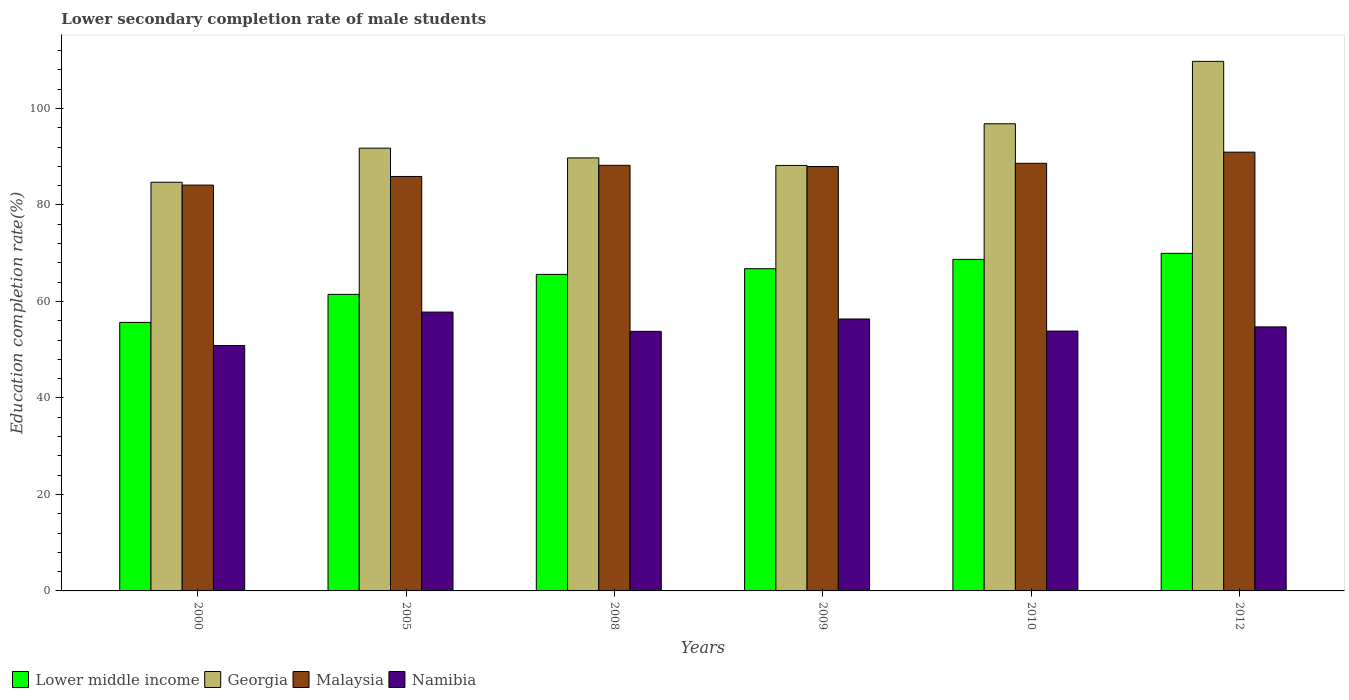How many different coloured bars are there?
Your response must be concise. 4. How many groups of bars are there?
Provide a short and direct response. 6. Are the number of bars per tick equal to the number of legend labels?
Your response must be concise. Yes. What is the lower secondary completion rate of male students in Namibia in 2005?
Keep it short and to the point. 57.8. Across all years, what is the maximum lower secondary completion rate of male students in Georgia?
Provide a succinct answer. 109.76. Across all years, what is the minimum lower secondary completion rate of male students in Namibia?
Keep it short and to the point. 50.86. In which year was the lower secondary completion rate of male students in Georgia maximum?
Provide a short and direct response. 2012. In which year was the lower secondary completion rate of male students in Malaysia minimum?
Ensure brevity in your answer.  2000. What is the total lower secondary completion rate of male students in Georgia in the graph?
Make the answer very short. 560.99. What is the difference between the lower secondary completion rate of male students in Lower middle income in 2008 and that in 2012?
Make the answer very short. -4.36. What is the difference between the lower secondary completion rate of male students in Georgia in 2005 and the lower secondary completion rate of male students in Namibia in 2012?
Keep it short and to the point. 37.04. What is the average lower secondary completion rate of male students in Georgia per year?
Your response must be concise. 93.5. In the year 2005, what is the difference between the lower secondary completion rate of male students in Georgia and lower secondary completion rate of male students in Namibia?
Your answer should be compact. 33.97. What is the ratio of the lower secondary completion rate of male students in Lower middle income in 2010 to that in 2012?
Offer a very short reply. 0.98. Is the lower secondary completion rate of male students in Namibia in 2008 less than that in 2009?
Your response must be concise. Yes. Is the difference between the lower secondary completion rate of male students in Georgia in 2009 and 2012 greater than the difference between the lower secondary completion rate of male students in Namibia in 2009 and 2012?
Give a very brief answer. No. What is the difference between the highest and the second highest lower secondary completion rate of male students in Malaysia?
Your answer should be compact. 2.31. What is the difference between the highest and the lowest lower secondary completion rate of male students in Lower middle income?
Provide a succinct answer. 14.31. Is the sum of the lower secondary completion rate of male students in Lower middle income in 2009 and 2010 greater than the maximum lower secondary completion rate of male students in Georgia across all years?
Your response must be concise. Yes. What does the 2nd bar from the left in 2010 represents?
Provide a short and direct response. Georgia. What does the 3rd bar from the right in 2000 represents?
Offer a terse response. Georgia. Is it the case that in every year, the sum of the lower secondary completion rate of male students in Malaysia and lower secondary completion rate of male students in Namibia is greater than the lower secondary completion rate of male students in Lower middle income?
Make the answer very short. Yes. How many bars are there?
Offer a terse response. 24. Does the graph contain any zero values?
Provide a succinct answer. No. Where does the legend appear in the graph?
Offer a terse response. Bottom left. How many legend labels are there?
Your answer should be compact. 4. What is the title of the graph?
Offer a terse response. Lower secondary completion rate of male students. What is the label or title of the X-axis?
Give a very brief answer. Years. What is the label or title of the Y-axis?
Offer a terse response. Education completion rate(%). What is the Education completion rate(%) of Lower middle income in 2000?
Offer a terse response. 55.66. What is the Education completion rate(%) of Georgia in 2000?
Make the answer very short. 84.7. What is the Education completion rate(%) in Malaysia in 2000?
Your answer should be very brief. 84.11. What is the Education completion rate(%) in Namibia in 2000?
Give a very brief answer. 50.86. What is the Education completion rate(%) of Lower middle income in 2005?
Provide a succinct answer. 61.47. What is the Education completion rate(%) of Georgia in 2005?
Keep it short and to the point. 91.77. What is the Education completion rate(%) in Malaysia in 2005?
Your answer should be very brief. 85.9. What is the Education completion rate(%) in Namibia in 2005?
Give a very brief answer. 57.8. What is the Education completion rate(%) of Lower middle income in 2008?
Keep it short and to the point. 65.6. What is the Education completion rate(%) of Georgia in 2008?
Offer a terse response. 89.75. What is the Education completion rate(%) of Malaysia in 2008?
Your answer should be compact. 88.21. What is the Education completion rate(%) of Namibia in 2008?
Make the answer very short. 53.8. What is the Education completion rate(%) of Lower middle income in 2009?
Make the answer very short. 66.78. What is the Education completion rate(%) in Georgia in 2009?
Offer a very short reply. 88.19. What is the Education completion rate(%) in Malaysia in 2009?
Keep it short and to the point. 87.96. What is the Education completion rate(%) in Namibia in 2009?
Your answer should be very brief. 56.36. What is the Education completion rate(%) of Lower middle income in 2010?
Make the answer very short. 68.71. What is the Education completion rate(%) of Georgia in 2010?
Give a very brief answer. 96.83. What is the Education completion rate(%) of Malaysia in 2010?
Offer a very short reply. 88.63. What is the Education completion rate(%) in Namibia in 2010?
Provide a short and direct response. 53.86. What is the Education completion rate(%) in Lower middle income in 2012?
Keep it short and to the point. 69.97. What is the Education completion rate(%) in Georgia in 2012?
Your answer should be compact. 109.76. What is the Education completion rate(%) of Malaysia in 2012?
Give a very brief answer. 90.94. What is the Education completion rate(%) of Namibia in 2012?
Make the answer very short. 54.73. Across all years, what is the maximum Education completion rate(%) in Lower middle income?
Your response must be concise. 69.97. Across all years, what is the maximum Education completion rate(%) in Georgia?
Your answer should be very brief. 109.76. Across all years, what is the maximum Education completion rate(%) in Malaysia?
Provide a succinct answer. 90.94. Across all years, what is the maximum Education completion rate(%) of Namibia?
Ensure brevity in your answer.  57.8. Across all years, what is the minimum Education completion rate(%) of Lower middle income?
Give a very brief answer. 55.66. Across all years, what is the minimum Education completion rate(%) in Georgia?
Give a very brief answer. 84.7. Across all years, what is the minimum Education completion rate(%) of Malaysia?
Offer a very short reply. 84.11. Across all years, what is the minimum Education completion rate(%) of Namibia?
Your answer should be very brief. 50.86. What is the total Education completion rate(%) of Lower middle income in the graph?
Your answer should be compact. 388.19. What is the total Education completion rate(%) in Georgia in the graph?
Ensure brevity in your answer.  560.99. What is the total Education completion rate(%) of Malaysia in the graph?
Make the answer very short. 525.76. What is the total Education completion rate(%) in Namibia in the graph?
Provide a succinct answer. 327.4. What is the difference between the Education completion rate(%) of Lower middle income in 2000 and that in 2005?
Keep it short and to the point. -5.81. What is the difference between the Education completion rate(%) of Georgia in 2000 and that in 2005?
Your answer should be compact. -7.07. What is the difference between the Education completion rate(%) of Malaysia in 2000 and that in 2005?
Offer a very short reply. -1.79. What is the difference between the Education completion rate(%) in Namibia in 2000 and that in 2005?
Make the answer very short. -6.94. What is the difference between the Education completion rate(%) in Lower middle income in 2000 and that in 2008?
Keep it short and to the point. -9.95. What is the difference between the Education completion rate(%) of Georgia in 2000 and that in 2008?
Your answer should be compact. -5.05. What is the difference between the Education completion rate(%) of Malaysia in 2000 and that in 2008?
Your answer should be very brief. -4.1. What is the difference between the Education completion rate(%) in Namibia in 2000 and that in 2008?
Keep it short and to the point. -2.94. What is the difference between the Education completion rate(%) in Lower middle income in 2000 and that in 2009?
Give a very brief answer. -11.13. What is the difference between the Education completion rate(%) in Georgia in 2000 and that in 2009?
Your response must be concise. -3.48. What is the difference between the Education completion rate(%) of Malaysia in 2000 and that in 2009?
Make the answer very short. -3.86. What is the difference between the Education completion rate(%) in Namibia in 2000 and that in 2009?
Offer a very short reply. -5.5. What is the difference between the Education completion rate(%) of Lower middle income in 2000 and that in 2010?
Your answer should be very brief. -13.06. What is the difference between the Education completion rate(%) in Georgia in 2000 and that in 2010?
Your answer should be compact. -12.13. What is the difference between the Education completion rate(%) of Malaysia in 2000 and that in 2010?
Keep it short and to the point. -4.52. What is the difference between the Education completion rate(%) of Namibia in 2000 and that in 2010?
Keep it short and to the point. -3. What is the difference between the Education completion rate(%) of Lower middle income in 2000 and that in 2012?
Provide a succinct answer. -14.31. What is the difference between the Education completion rate(%) of Georgia in 2000 and that in 2012?
Keep it short and to the point. -25.06. What is the difference between the Education completion rate(%) in Malaysia in 2000 and that in 2012?
Your answer should be very brief. -6.84. What is the difference between the Education completion rate(%) in Namibia in 2000 and that in 2012?
Your answer should be compact. -3.87. What is the difference between the Education completion rate(%) in Lower middle income in 2005 and that in 2008?
Ensure brevity in your answer.  -4.14. What is the difference between the Education completion rate(%) in Georgia in 2005 and that in 2008?
Your answer should be very brief. 2.02. What is the difference between the Education completion rate(%) in Malaysia in 2005 and that in 2008?
Your answer should be very brief. -2.31. What is the difference between the Education completion rate(%) of Namibia in 2005 and that in 2008?
Make the answer very short. 3.99. What is the difference between the Education completion rate(%) of Lower middle income in 2005 and that in 2009?
Your response must be concise. -5.32. What is the difference between the Education completion rate(%) in Georgia in 2005 and that in 2009?
Provide a short and direct response. 3.58. What is the difference between the Education completion rate(%) in Malaysia in 2005 and that in 2009?
Provide a succinct answer. -2.06. What is the difference between the Education completion rate(%) of Namibia in 2005 and that in 2009?
Provide a short and direct response. 1.43. What is the difference between the Education completion rate(%) in Lower middle income in 2005 and that in 2010?
Provide a succinct answer. -7.25. What is the difference between the Education completion rate(%) of Georgia in 2005 and that in 2010?
Make the answer very short. -5.06. What is the difference between the Education completion rate(%) in Malaysia in 2005 and that in 2010?
Your answer should be compact. -2.73. What is the difference between the Education completion rate(%) of Namibia in 2005 and that in 2010?
Your response must be concise. 3.94. What is the difference between the Education completion rate(%) of Lower middle income in 2005 and that in 2012?
Offer a very short reply. -8.5. What is the difference between the Education completion rate(%) of Georgia in 2005 and that in 2012?
Provide a short and direct response. -17.99. What is the difference between the Education completion rate(%) of Malaysia in 2005 and that in 2012?
Make the answer very short. -5.04. What is the difference between the Education completion rate(%) in Namibia in 2005 and that in 2012?
Offer a terse response. 3.07. What is the difference between the Education completion rate(%) of Lower middle income in 2008 and that in 2009?
Make the answer very short. -1.18. What is the difference between the Education completion rate(%) in Georgia in 2008 and that in 2009?
Keep it short and to the point. 1.56. What is the difference between the Education completion rate(%) in Malaysia in 2008 and that in 2009?
Give a very brief answer. 0.25. What is the difference between the Education completion rate(%) of Namibia in 2008 and that in 2009?
Provide a short and direct response. -2.56. What is the difference between the Education completion rate(%) in Lower middle income in 2008 and that in 2010?
Offer a very short reply. -3.11. What is the difference between the Education completion rate(%) of Georgia in 2008 and that in 2010?
Give a very brief answer. -7.08. What is the difference between the Education completion rate(%) in Malaysia in 2008 and that in 2010?
Your answer should be very brief. -0.42. What is the difference between the Education completion rate(%) of Namibia in 2008 and that in 2010?
Offer a terse response. -0.05. What is the difference between the Education completion rate(%) in Lower middle income in 2008 and that in 2012?
Your response must be concise. -4.36. What is the difference between the Education completion rate(%) of Georgia in 2008 and that in 2012?
Your answer should be compact. -20.01. What is the difference between the Education completion rate(%) in Malaysia in 2008 and that in 2012?
Offer a very short reply. -2.73. What is the difference between the Education completion rate(%) of Namibia in 2008 and that in 2012?
Make the answer very short. -0.92. What is the difference between the Education completion rate(%) in Lower middle income in 2009 and that in 2010?
Your answer should be very brief. -1.93. What is the difference between the Education completion rate(%) in Georgia in 2009 and that in 2010?
Ensure brevity in your answer.  -8.64. What is the difference between the Education completion rate(%) in Malaysia in 2009 and that in 2010?
Offer a terse response. -0.67. What is the difference between the Education completion rate(%) of Namibia in 2009 and that in 2010?
Your answer should be compact. 2.5. What is the difference between the Education completion rate(%) in Lower middle income in 2009 and that in 2012?
Offer a very short reply. -3.18. What is the difference between the Education completion rate(%) of Georgia in 2009 and that in 2012?
Ensure brevity in your answer.  -21.57. What is the difference between the Education completion rate(%) in Malaysia in 2009 and that in 2012?
Your answer should be very brief. -2.98. What is the difference between the Education completion rate(%) in Namibia in 2009 and that in 2012?
Your answer should be compact. 1.64. What is the difference between the Education completion rate(%) in Lower middle income in 2010 and that in 2012?
Offer a very short reply. -1.25. What is the difference between the Education completion rate(%) in Georgia in 2010 and that in 2012?
Your answer should be very brief. -12.93. What is the difference between the Education completion rate(%) of Malaysia in 2010 and that in 2012?
Ensure brevity in your answer.  -2.31. What is the difference between the Education completion rate(%) of Namibia in 2010 and that in 2012?
Your answer should be very brief. -0.87. What is the difference between the Education completion rate(%) in Lower middle income in 2000 and the Education completion rate(%) in Georgia in 2005?
Keep it short and to the point. -36.11. What is the difference between the Education completion rate(%) in Lower middle income in 2000 and the Education completion rate(%) in Malaysia in 2005?
Your answer should be compact. -30.25. What is the difference between the Education completion rate(%) in Lower middle income in 2000 and the Education completion rate(%) in Namibia in 2005?
Provide a succinct answer. -2.14. What is the difference between the Education completion rate(%) in Georgia in 2000 and the Education completion rate(%) in Malaysia in 2005?
Give a very brief answer. -1.2. What is the difference between the Education completion rate(%) in Georgia in 2000 and the Education completion rate(%) in Namibia in 2005?
Ensure brevity in your answer.  26.91. What is the difference between the Education completion rate(%) of Malaysia in 2000 and the Education completion rate(%) of Namibia in 2005?
Give a very brief answer. 26.31. What is the difference between the Education completion rate(%) in Lower middle income in 2000 and the Education completion rate(%) in Georgia in 2008?
Provide a short and direct response. -34.09. What is the difference between the Education completion rate(%) of Lower middle income in 2000 and the Education completion rate(%) of Malaysia in 2008?
Offer a terse response. -32.55. What is the difference between the Education completion rate(%) in Lower middle income in 2000 and the Education completion rate(%) in Namibia in 2008?
Give a very brief answer. 1.85. What is the difference between the Education completion rate(%) in Georgia in 2000 and the Education completion rate(%) in Malaysia in 2008?
Your answer should be compact. -3.51. What is the difference between the Education completion rate(%) of Georgia in 2000 and the Education completion rate(%) of Namibia in 2008?
Keep it short and to the point. 30.9. What is the difference between the Education completion rate(%) in Malaysia in 2000 and the Education completion rate(%) in Namibia in 2008?
Ensure brevity in your answer.  30.3. What is the difference between the Education completion rate(%) in Lower middle income in 2000 and the Education completion rate(%) in Georgia in 2009?
Your response must be concise. -32.53. What is the difference between the Education completion rate(%) in Lower middle income in 2000 and the Education completion rate(%) in Malaysia in 2009?
Offer a very short reply. -32.31. What is the difference between the Education completion rate(%) in Lower middle income in 2000 and the Education completion rate(%) in Namibia in 2009?
Give a very brief answer. -0.71. What is the difference between the Education completion rate(%) of Georgia in 2000 and the Education completion rate(%) of Malaysia in 2009?
Your answer should be very brief. -3.26. What is the difference between the Education completion rate(%) of Georgia in 2000 and the Education completion rate(%) of Namibia in 2009?
Provide a short and direct response. 28.34. What is the difference between the Education completion rate(%) of Malaysia in 2000 and the Education completion rate(%) of Namibia in 2009?
Make the answer very short. 27.75. What is the difference between the Education completion rate(%) of Lower middle income in 2000 and the Education completion rate(%) of Georgia in 2010?
Ensure brevity in your answer.  -41.17. What is the difference between the Education completion rate(%) in Lower middle income in 2000 and the Education completion rate(%) in Malaysia in 2010?
Provide a succinct answer. -32.97. What is the difference between the Education completion rate(%) of Lower middle income in 2000 and the Education completion rate(%) of Namibia in 2010?
Make the answer very short. 1.8. What is the difference between the Education completion rate(%) in Georgia in 2000 and the Education completion rate(%) in Malaysia in 2010?
Your answer should be very brief. -3.93. What is the difference between the Education completion rate(%) of Georgia in 2000 and the Education completion rate(%) of Namibia in 2010?
Offer a very short reply. 30.84. What is the difference between the Education completion rate(%) of Malaysia in 2000 and the Education completion rate(%) of Namibia in 2010?
Make the answer very short. 30.25. What is the difference between the Education completion rate(%) of Lower middle income in 2000 and the Education completion rate(%) of Georgia in 2012?
Your answer should be compact. -54.1. What is the difference between the Education completion rate(%) of Lower middle income in 2000 and the Education completion rate(%) of Malaysia in 2012?
Your response must be concise. -35.29. What is the difference between the Education completion rate(%) of Georgia in 2000 and the Education completion rate(%) of Malaysia in 2012?
Provide a succinct answer. -6.24. What is the difference between the Education completion rate(%) of Georgia in 2000 and the Education completion rate(%) of Namibia in 2012?
Provide a succinct answer. 29.98. What is the difference between the Education completion rate(%) of Malaysia in 2000 and the Education completion rate(%) of Namibia in 2012?
Make the answer very short. 29.38. What is the difference between the Education completion rate(%) of Lower middle income in 2005 and the Education completion rate(%) of Georgia in 2008?
Offer a terse response. -28.28. What is the difference between the Education completion rate(%) of Lower middle income in 2005 and the Education completion rate(%) of Malaysia in 2008?
Your answer should be very brief. -26.74. What is the difference between the Education completion rate(%) of Lower middle income in 2005 and the Education completion rate(%) of Namibia in 2008?
Your answer should be compact. 7.66. What is the difference between the Education completion rate(%) in Georgia in 2005 and the Education completion rate(%) in Malaysia in 2008?
Make the answer very short. 3.56. What is the difference between the Education completion rate(%) in Georgia in 2005 and the Education completion rate(%) in Namibia in 2008?
Your answer should be compact. 37.96. What is the difference between the Education completion rate(%) of Malaysia in 2005 and the Education completion rate(%) of Namibia in 2008?
Provide a short and direct response. 32.1. What is the difference between the Education completion rate(%) in Lower middle income in 2005 and the Education completion rate(%) in Georgia in 2009?
Make the answer very short. -26.72. What is the difference between the Education completion rate(%) in Lower middle income in 2005 and the Education completion rate(%) in Malaysia in 2009?
Give a very brief answer. -26.5. What is the difference between the Education completion rate(%) of Lower middle income in 2005 and the Education completion rate(%) of Namibia in 2009?
Your answer should be very brief. 5.1. What is the difference between the Education completion rate(%) in Georgia in 2005 and the Education completion rate(%) in Malaysia in 2009?
Provide a succinct answer. 3.8. What is the difference between the Education completion rate(%) in Georgia in 2005 and the Education completion rate(%) in Namibia in 2009?
Provide a short and direct response. 35.41. What is the difference between the Education completion rate(%) of Malaysia in 2005 and the Education completion rate(%) of Namibia in 2009?
Offer a terse response. 29.54. What is the difference between the Education completion rate(%) of Lower middle income in 2005 and the Education completion rate(%) of Georgia in 2010?
Give a very brief answer. -35.36. What is the difference between the Education completion rate(%) of Lower middle income in 2005 and the Education completion rate(%) of Malaysia in 2010?
Your answer should be compact. -27.16. What is the difference between the Education completion rate(%) of Lower middle income in 2005 and the Education completion rate(%) of Namibia in 2010?
Give a very brief answer. 7.61. What is the difference between the Education completion rate(%) in Georgia in 2005 and the Education completion rate(%) in Malaysia in 2010?
Ensure brevity in your answer.  3.14. What is the difference between the Education completion rate(%) of Georgia in 2005 and the Education completion rate(%) of Namibia in 2010?
Give a very brief answer. 37.91. What is the difference between the Education completion rate(%) of Malaysia in 2005 and the Education completion rate(%) of Namibia in 2010?
Provide a succinct answer. 32.04. What is the difference between the Education completion rate(%) of Lower middle income in 2005 and the Education completion rate(%) of Georgia in 2012?
Offer a very short reply. -48.29. What is the difference between the Education completion rate(%) in Lower middle income in 2005 and the Education completion rate(%) in Malaysia in 2012?
Provide a succinct answer. -29.48. What is the difference between the Education completion rate(%) of Lower middle income in 2005 and the Education completion rate(%) of Namibia in 2012?
Keep it short and to the point. 6.74. What is the difference between the Education completion rate(%) in Georgia in 2005 and the Education completion rate(%) in Malaysia in 2012?
Keep it short and to the point. 0.83. What is the difference between the Education completion rate(%) of Georgia in 2005 and the Education completion rate(%) of Namibia in 2012?
Give a very brief answer. 37.04. What is the difference between the Education completion rate(%) in Malaysia in 2005 and the Education completion rate(%) in Namibia in 2012?
Provide a succinct answer. 31.18. What is the difference between the Education completion rate(%) of Lower middle income in 2008 and the Education completion rate(%) of Georgia in 2009?
Provide a short and direct response. -22.58. What is the difference between the Education completion rate(%) in Lower middle income in 2008 and the Education completion rate(%) in Malaysia in 2009?
Provide a short and direct response. -22.36. What is the difference between the Education completion rate(%) of Lower middle income in 2008 and the Education completion rate(%) of Namibia in 2009?
Give a very brief answer. 9.24. What is the difference between the Education completion rate(%) in Georgia in 2008 and the Education completion rate(%) in Malaysia in 2009?
Your answer should be compact. 1.79. What is the difference between the Education completion rate(%) of Georgia in 2008 and the Education completion rate(%) of Namibia in 2009?
Ensure brevity in your answer.  33.39. What is the difference between the Education completion rate(%) of Malaysia in 2008 and the Education completion rate(%) of Namibia in 2009?
Offer a terse response. 31.85. What is the difference between the Education completion rate(%) in Lower middle income in 2008 and the Education completion rate(%) in Georgia in 2010?
Ensure brevity in your answer.  -31.22. What is the difference between the Education completion rate(%) of Lower middle income in 2008 and the Education completion rate(%) of Malaysia in 2010?
Offer a terse response. -23.03. What is the difference between the Education completion rate(%) of Lower middle income in 2008 and the Education completion rate(%) of Namibia in 2010?
Offer a very short reply. 11.75. What is the difference between the Education completion rate(%) of Georgia in 2008 and the Education completion rate(%) of Malaysia in 2010?
Ensure brevity in your answer.  1.12. What is the difference between the Education completion rate(%) in Georgia in 2008 and the Education completion rate(%) in Namibia in 2010?
Give a very brief answer. 35.89. What is the difference between the Education completion rate(%) of Malaysia in 2008 and the Education completion rate(%) of Namibia in 2010?
Provide a succinct answer. 34.35. What is the difference between the Education completion rate(%) of Lower middle income in 2008 and the Education completion rate(%) of Georgia in 2012?
Provide a succinct answer. -44.16. What is the difference between the Education completion rate(%) of Lower middle income in 2008 and the Education completion rate(%) of Malaysia in 2012?
Your answer should be very brief. -25.34. What is the difference between the Education completion rate(%) in Lower middle income in 2008 and the Education completion rate(%) in Namibia in 2012?
Make the answer very short. 10.88. What is the difference between the Education completion rate(%) in Georgia in 2008 and the Education completion rate(%) in Malaysia in 2012?
Your answer should be compact. -1.19. What is the difference between the Education completion rate(%) in Georgia in 2008 and the Education completion rate(%) in Namibia in 2012?
Offer a terse response. 35.02. What is the difference between the Education completion rate(%) in Malaysia in 2008 and the Education completion rate(%) in Namibia in 2012?
Provide a succinct answer. 33.48. What is the difference between the Education completion rate(%) of Lower middle income in 2009 and the Education completion rate(%) of Georgia in 2010?
Your answer should be very brief. -30.04. What is the difference between the Education completion rate(%) in Lower middle income in 2009 and the Education completion rate(%) in Malaysia in 2010?
Offer a terse response. -21.85. What is the difference between the Education completion rate(%) of Lower middle income in 2009 and the Education completion rate(%) of Namibia in 2010?
Your answer should be very brief. 12.93. What is the difference between the Education completion rate(%) in Georgia in 2009 and the Education completion rate(%) in Malaysia in 2010?
Your answer should be very brief. -0.45. What is the difference between the Education completion rate(%) of Georgia in 2009 and the Education completion rate(%) of Namibia in 2010?
Offer a very short reply. 34.33. What is the difference between the Education completion rate(%) in Malaysia in 2009 and the Education completion rate(%) in Namibia in 2010?
Provide a short and direct response. 34.11. What is the difference between the Education completion rate(%) in Lower middle income in 2009 and the Education completion rate(%) in Georgia in 2012?
Offer a very short reply. -42.98. What is the difference between the Education completion rate(%) of Lower middle income in 2009 and the Education completion rate(%) of Malaysia in 2012?
Make the answer very short. -24.16. What is the difference between the Education completion rate(%) of Lower middle income in 2009 and the Education completion rate(%) of Namibia in 2012?
Your response must be concise. 12.06. What is the difference between the Education completion rate(%) in Georgia in 2009 and the Education completion rate(%) in Malaysia in 2012?
Keep it short and to the point. -2.76. What is the difference between the Education completion rate(%) in Georgia in 2009 and the Education completion rate(%) in Namibia in 2012?
Make the answer very short. 33.46. What is the difference between the Education completion rate(%) of Malaysia in 2009 and the Education completion rate(%) of Namibia in 2012?
Offer a very short reply. 33.24. What is the difference between the Education completion rate(%) in Lower middle income in 2010 and the Education completion rate(%) in Georgia in 2012?
Your answer should be very brief. -41.05. What is the difference between the Education completion rate(%) in Lower middle income in 2010 and the Education completion rate(%) in Malaysia in 2012?
Your response must be concise. -22.23. What is the difference between the Education completion rate(%) in Lower middle income in 2010 and the Education completion rate(%) in Namibia in 2012?
Make the answer very short. 13.99. What is the difference between the Education completion rate(%) of Georgia in 2010 and the Education completion rate(%) of Malaysia in 2012?
Your answer should be very brief. 5.88. What is the difference between the Education completion rate(%) in Georgia in 2010 and the Education completion rate(%) in Namibia in 2012?
Offer a terse response. 42.1. What is the difference between the Education completion rate(%) in Malaysia in 2010 and the Education completion rate(%) in Namibia in 2012?
Make the answer very short. 33.9. What is the average Education completion rate(%) in Lower middle income per year?
Offer a terse response. 64.7. What is the average Education completion rate(%) in Georgia per year?
Ensure brevity in your answer.  93.5. What is the average Education completion rate(%) of Malaysia per year?
Your answer should be compact. 87.63. What is the average Education completion rate(%) of Namibia per year?
Your answer should be compact. 54.57. In the year 2000, what is the difference between the Education completion rate(%) of Lower middle income and Education completion rate(%) of Georgia?
Offer a terse response. -29.05. In the year 2000, what is the difference between the Education completion rate(%) in Lower middle income and Education completion rate(%) in Malaysia?
Your answer should be very brief. -28.45. In the year 2000, what is the difference between the Education completion rate(%) of Lower middle income and Education completion rate(%) of Namibia?
Give a very brief answer. 4.8. In the year 2000, what is the difference between the Education completion rate(%) in Georgia and Education completion rate(%) in Malaysia?
Offer a very short reply. 0.59. In the year 2000, what is the difference between the Education completion rate(%) of Georgia and Education completion rate(%) of Namibia?
Give a very brief answer. 33.84. In the year 2000, what is the difference between the Education completion rate(%) of Malaysia and Education completion rate(%) of Namibia?
Make the answer very short. 33.25. In the year 2005, what is the difference between the Education completion rate(%) of Lower middle income and Education completion rate(%) of Georgia?
Offer a very short reply. -30.3. In the year 2005, what is the difference between the Education completion rate(%) of Lower middle income and Education completion rate(%) of Malaysia?
Offer a very short reply. -24.43. In the year 2005, what is the difference between the Education completion rate(%) of Lower middle income and Education completion rate(%) of Namibia?
Offer a terse response. 3.67. In the year 2005, what is the difference between the Education completion rate(%) of Georgia and Education completion rate(%) of Malaysia?
Ensure brevity in your answer.  5.87. In the year 2005, what is the difference between the Education completion rate(%) in Georgia and Education completion rate(%) in Namibia?
Ensure brevity in your answer.  33.97. In the year 2005, what is the difference between the Education completion rate(%) in Malaysia and Education completion rate(%) in Namibia?
Make the answer very short. 28.11. In the year 2008, what is the difference between the Education completion rate(%) in Lower middle income and Education completion rate(%) in Georgia?
Your answer should be compact. -24.14. In the year 2008, what is the difference between the Education completion rate(%) in Lower middle income and Education completion rate(%) in Malaysia?
Make the answer very short. -22.61. In the year 2008, what is the difference between the Education completion rate(%) of Lower middle income and Education completion rate(%) of Namibia?
Keep it short and to the point. 11.8. In the year 2008, what is the difference between the Education completion rate(%) in Georgia and Education completion rate(%) in Malaysia?
Offer a very short reply. 1.54. In the year 2008, what is the difference between the Education completion rate(%) of Georgia and Education completion rate(%) of Namibia?
Ensure brevity in your answer.  35.95. In the year 2008, what is the difference between the Education completion rate(%) in Malaysia and Education completion rate(%) in Namibia?
Make the answer very short. 34.41. In the year 2009, what is the difference between the Education completion rate(%) in Lower middle income and Education completion rate(%) in Georgia?
Give a very brief answer. -21.4. In the year 2009, what is the difference between the Education completion rate(%) of Lower middle income and Education completion rate(%) of Malaysia?
Your answer should be compact. -21.18. In the year 2009, what is the difference between the Education completion rate(%) of Lower middle income and Education completion rate(%) of Namibia?
Offer a very short reply. 10.42. In the year 2009, what is the difference between the Education completion rate(%) in Georgia and Education completion rate(%) in Malaysia?
Provide a succinct answer. 0.22. In the year 2009, what is the difference between the Education completion rate(%) of Georgia and Education completion rate(%) of Namibia?
Your answer should be compact. 31.82. In the year 2009, what is the difference between the Education completion rate(%) of Malaysia and Education completion rate(%) of Namibia?
Provide a succinct answer. 31.6. In the year 2010, what is the difference between the Education completion rate(%) in Lower middle income and Education completion rate(%) in Georgia?
Your response must be concise. -28.11. In the year 2010, what is the difference between the Education completion rate(%) of Lower middle income and Education completion rate(%) of Malaysia?
Your answer should be very brief. -19.92. In the year 2010, what is the difference between the Education completion rate(%) of Lower middle income and Education completion rate(%) of Namibia?
Give a very brief answer. 14.86. In the year 2010, what is the difference between the Education completion rate(%) in Georgia and Education completion rate(%) in Malaysia?
Provide a succinct answer. 8.2. In the year 2010, what is the difference between the Education completion rate(%) of Georgia and Education completion rate(%) of Namibia?
Make the answer very short. 42.97. In the year 2010, what is the difference between the Education completion rate(%) of Malaysia and Education completion rate(%) of Namibia?
Keep it short and to the point. 34.77. In the year 2012, what is the difference between the Education completion rate(%) in Lower middle income and Education completion rate(%) in Georgia?
Provide a short and direct response. -39.79. In the year 2012, what is the difference between the Education completion rate(%) of Lower middle income and Education completion rate(%) of Malaysia?
Your response must be concise. -20.97. In the year 2012, what is the difference between the Education completion rate(%) in Lower middle income and Education completion rate(%) in Namibia?
Offer a terse response. 15.24. In the year 2012, what is the difference between the Education completion rate(%) in Georgia and Education completion rate(%) in Malaysia?
Give a very brief answer. 18.82. In the year 2012, what is the difference between the Education completion rate(%) of Georgia and Education completion rate(%) of Namibia?
Your answer should be compact. 55.03. In the year 2012, what is the difference between the Education completion rate(%) in Malaysia and Education completion rate(%) in Namibia?
Your response must be concise. 36.22. What is the ratio of the Education completion rate(%) in Lower middle income in 2000 to that in 2005?
Provide a succinct answer. 0.91. What is the ratio of the Education completion rate(%) in Georgia in 2000 to that in 2005?
Provide a succinct answer. 0.92. What is the ratio of the Education completion rate(%) of Malaysia in 2000 to that in 2005?
Your answer should be compact. 0.98. What is the ratio of the Education completion rate(%) of Namibia in 2000 to that in 2005?
Your answer should be very brief. 0.88. What is the ratio of the Education completion rate(%) of Lower middle income in 2000 to that in 2008?
Ensure brevity in your answer.  0.85. What is the ratio of the Education completion rate(%) in Georgia in 2000 to that in 2008?
Provide a succinct answer. 0.94. What is the ratio of the Education completion rate(%) of Malaysia in 2000 to that in 2008?
Your answer should be compact. 0.95. What is the ratio of the Education completion rate(%) of Namibia in 2000 to that in 2008?
Give a very brief answer. 0.95. What is the ratio of the Education completion rate(%) of Lower middle income in 2000 to that in 2009?
Your response must be concise. 0.83. What is the ratio of the Education completion rate(%) in Georgia in 2000 to that in 2009?
Your answer should be compact. 0.96. What is the ratio of the Education completion rate(%) in Malaysia in 2000 to that in 2009?
Your response must be concise. 0.96. What is the ratio of the Education completion rate(%) in Namibia in 2000 to that in 2009?
Your answer should be compact. 0.9. What is the ratio of the Education completion rate(%) in Lower middle income in 2000 to that in 2010?
Provide a succinct answer. 0.81. What is the ratio of the Education completion rate(%) of Georgia in 2000 to that in 2010?
Provide a short and direct response. 0.87. What is the ratio of the Education completion rate(%) of Malaysia in 2000 to that in 2010?
Provide a succinct answer. 0.95. What is the ratio of the Education completion rate(%) of Namibia in 2000 to that in 2010?
Make the answer very short. 0.94. What is the ratio of the Education completion rate(%) in Lower middle income in 2000 to that in 2012?
Provide a short and direct response. 0.8. What is the ratio of the Education completion rate(%) of Georgia in 2000 to that in 2012?
Your answer should be compact. 0.77. What is the ratio of the Education completion rate(%) in Malaysia in 2000 to that in 2012?
Offer a terse response. 0.92. What is the ratio of the Education completion rate(%) in Namibia in 2000 to that in 2012?
Give a very brief answer. 0.93. What is the ratio of the Education completion rate(%) of Lower middle income in 2005 to that in 2008?
Offer a very short reply. 0.94. What is the ratio of the Education completion rate(%) in Georgia in 2005 to that in 2008?
Offer a terse response. 1.02. What is the ratio of the Education completion rate(%) of Malaysia in 2005 to that in 2008?
Ensure brevity in your answer.  0.97. What is the ratio of the Education completion rate(%) in Namibia in 2005 to that in 2008?
Give a very brief answer. 1.07. What is the ratio of the Education completion rate(%) in Lower middle income in 2005 to that in 2009?
Your answer should be very brief. 0.92. What is the ratio of the Education completion rate(%) of Georgia in 2005 to that in 2009?
Give a very brief answer. 1.04. What is the ratio of the Education completion rate(%) of Malaysia in 2005 to that in 2009?
Your answer should be compact. 0.98. What is the ratio of the Education completion rate(%) in Namibia in 2005 to that in 2009?
Your answer should be compact. 1.03. What is the ratio of the Education completion rate(%) of Lower middle income in 2005 to that in 2010?
Provide a short and direct response. 0.89. What is the ratio of the Education completion rate(%) of Georgia in 2005 to that in 2010?
Your answer should be very brief. 0.95. What is the ratio of the Education completion rate(%) of Malaysia in 2005 to that in 2010?
Your answer should be compact. 0.97. What is the ratio of the Education completion rate(%) in Namibia in 2005 to that in 2010?
Provide a short and direct response. 1.07. What is the ratio of the Education completion rate(%) in Lower middle income in 2005 to that in 2012?
Your response must be concise. 0.88. What is the ratio of the Education completion rate(%) of Georgia in 2005 to that in 2012?
Give a very brief answer. 0.84. What is the ratio of the Education completion rate(%) of Malaysia in 2005 to that in 2012?
Provide a succinct answer. 0.94. What is the ratio of the Education completion rate(%) of Namibia in 2005 to that in 2012?
Offer a terse response. 1.06. What is the ratio of the Education completion rate(%) in Lower middle income in 2008 to that in 2009?
Make the answer very short. 0.98. What is the ratio of the Education completion rate(%) of Georgia in 2008 to that in 2009?
Provide a short and direct response. 1.02. What is the ratio of the Education completion rate(%) of Namibia in 2008 to that in 2009?
Your answer should be compact. 0.95. What is the ratio of the Education completion rate(%) in Lower middle income in 2008 to that in 2010?
Keep it short and to the point. 0.95. What is the ratio of the Education completion rate(%) in Georgia in 2008 to that in 2010?
Keep it short and to the point. 0.93. What is the ratio of the Education completion rate(%) in Malaysia in 2008 to that in 2010?
Keep it short and to the point. 1. What is the ratio of the Education completion rate(%) of Lower middle income in 2008 to that in 2012?
Give a very brief answer. 0.94. What is the ratio of the Education completion rate(%) in Georgia in 2008 to that in 2012?
Offer a terse response. 0.82. What is the ratio of the Education completion rate(%) of Namibia in 2008 to that in 2012?
Provide a succinct answer. 0.98. What is the ratio of the Education completion rate(%) of Lower middle income in 2009 to that in 2010?
Ensure brevity in your answer.  0.97. What is the ratio of the Education completion rate(%) in Georgia in 2009 to that in 2010?
Your response must be concise. 0.91. What is the ratio of the Education completion rate(%) of Namibia in 2009 to that in 2010?
Provide a succinct answer. 1.05. What is the ratio of the Education completion rate(%) in Lower middle income in 2009 to that in 2012?
Provide a short and direct response. 0.95. What is the ratio of the Education completion rate(%) of Georgia in 2009 to that in 2012?
Make the answer very short. 0.8. What is the ratio of the Education completion rate(%) in Malaysia in 2009 to that in 2012?
Your answer should be compact. 0.97. What is the ratio of the Education completion rate(%) in Namibia in 2009 to that in 2012?
Your answer should be very brief. 1.03. What is the ratio of the Education completion rate(%) in Lower middle income in 2010 to that in 2012?
Make the answer very short. 0.98. What is the ratio of the Education completion rate(%) in Georgia in 2010 to that in 2012?
Your answer should be compact. 0.88. What is the ratio of the Education completion rate(%) in Malaysia in 2010 to that in 2012?
Give a very brief answer. 0.97. What is the ratio of the Education completion rate(%) of Namibia in 2010 to that in 2012?
Offer a very short reply. 0.98. What is the difference between the highest and the second highest Education completion rate(%) in Lower middle income?
Provide a short and direct response. 1.25. What is the difference between the highest and the second highest Education completion rate(%) in Georgia?
Keep it short and to the point. 12.93. What is the difference between the highest and the second highest Education completion rate(%) of Malaysia?
Ensure brevity in your answer.  2.31. What is the difference between the highest and the second highest Education completion rate(%) in Namibia?
Offer a very short reply. 1.43. What is the difference between the highest and the lowest Education completion rate(%) of Lower middle income?
Your answer should be compact. 14.31. What is the difference between the highest and the lowest Education completion rate(%) of Georgia?
Provide a succinct answer. 25.06. What is the difference between the highest and the lowest Education completion rate(%) in Malaysia?
Ensure brevity in your answer.  6.84. What is the difference between the highest and the lowest Education completion rate(%) in Namibia?
Give a very brief answer. 6.94. 